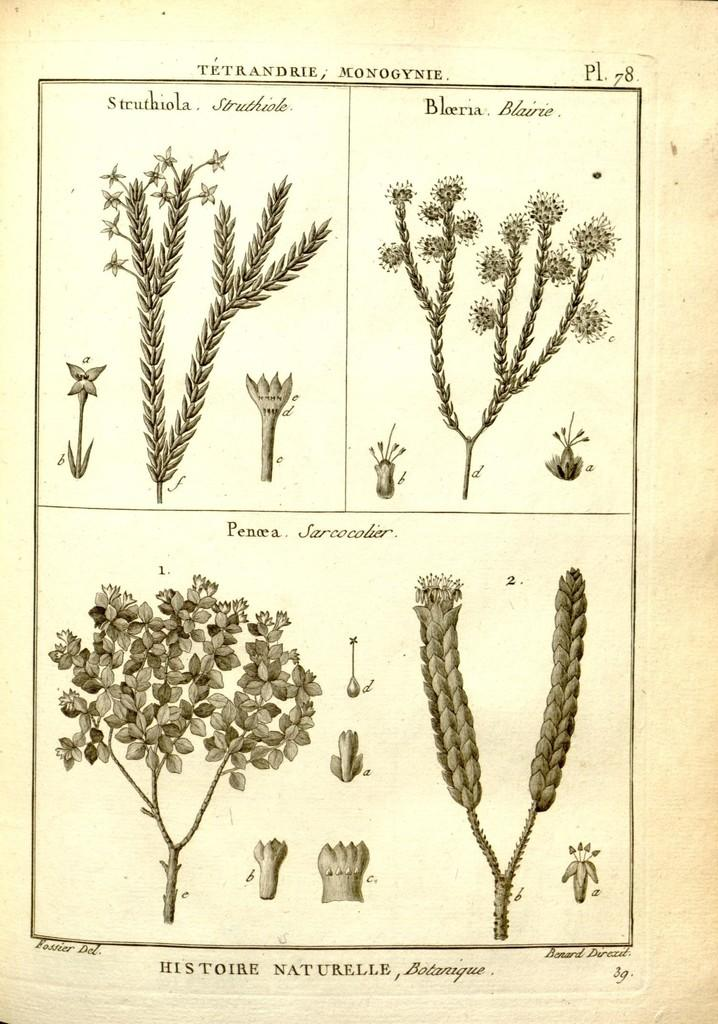What is depicted in the image? There is a sketch of plants in the image. Is there any text or writing in the image? Yes, there is something written on the image. What hobbies does the brother of the passenger have, as depicted in the image? There is no reference to a brother or passenger in the image, so it is not possible to answer that question. 